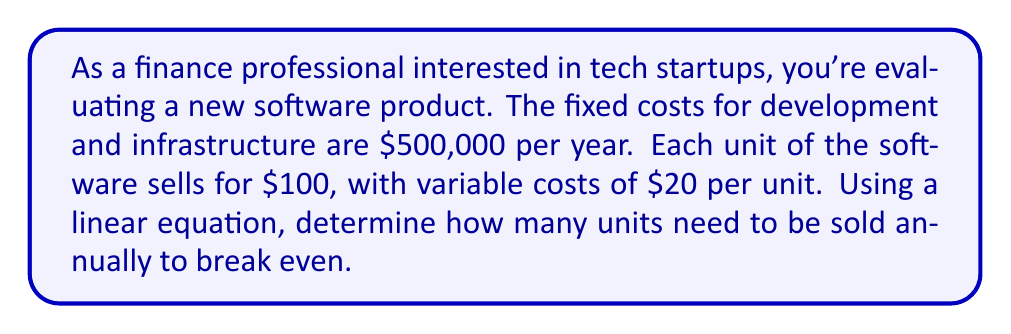What is the answer to this math problem? Let's approach this step-by-step using a linear equation:

1) Define variables:
   Let $x$ = number of units sold
   Let $y$ = total revenue

2) Express fixed costs:
   Fixed costs (FC) = $500,000

3) Express variable costs:
   Variable costs per unit (VC) = $20
   Total variable costs = $20x

4) Express revenue:
   Price per unit = $100
   Total revenue = $100x

5) Set up the break-even equation:
   At break-even point, Total Revenue = Total Costs
   $$100x = 500,000 + 20x$$

6) Solve the equation:
   $$100x - 20x = 500,000$$
   $$80x = 500,000$$
   $$x = \frac{500,000}{80} = 6,250$$

Therefore, the company needs to sell 6,250 units annually to break even.

To verify:
Revenue: $100 * 6,250 = $625,000
Total Costs: $500,000 + ($20 * 6,250) = $625,000

Revenue equals Total Costs, confirming the break-even point.
Answer: 6,250 units 